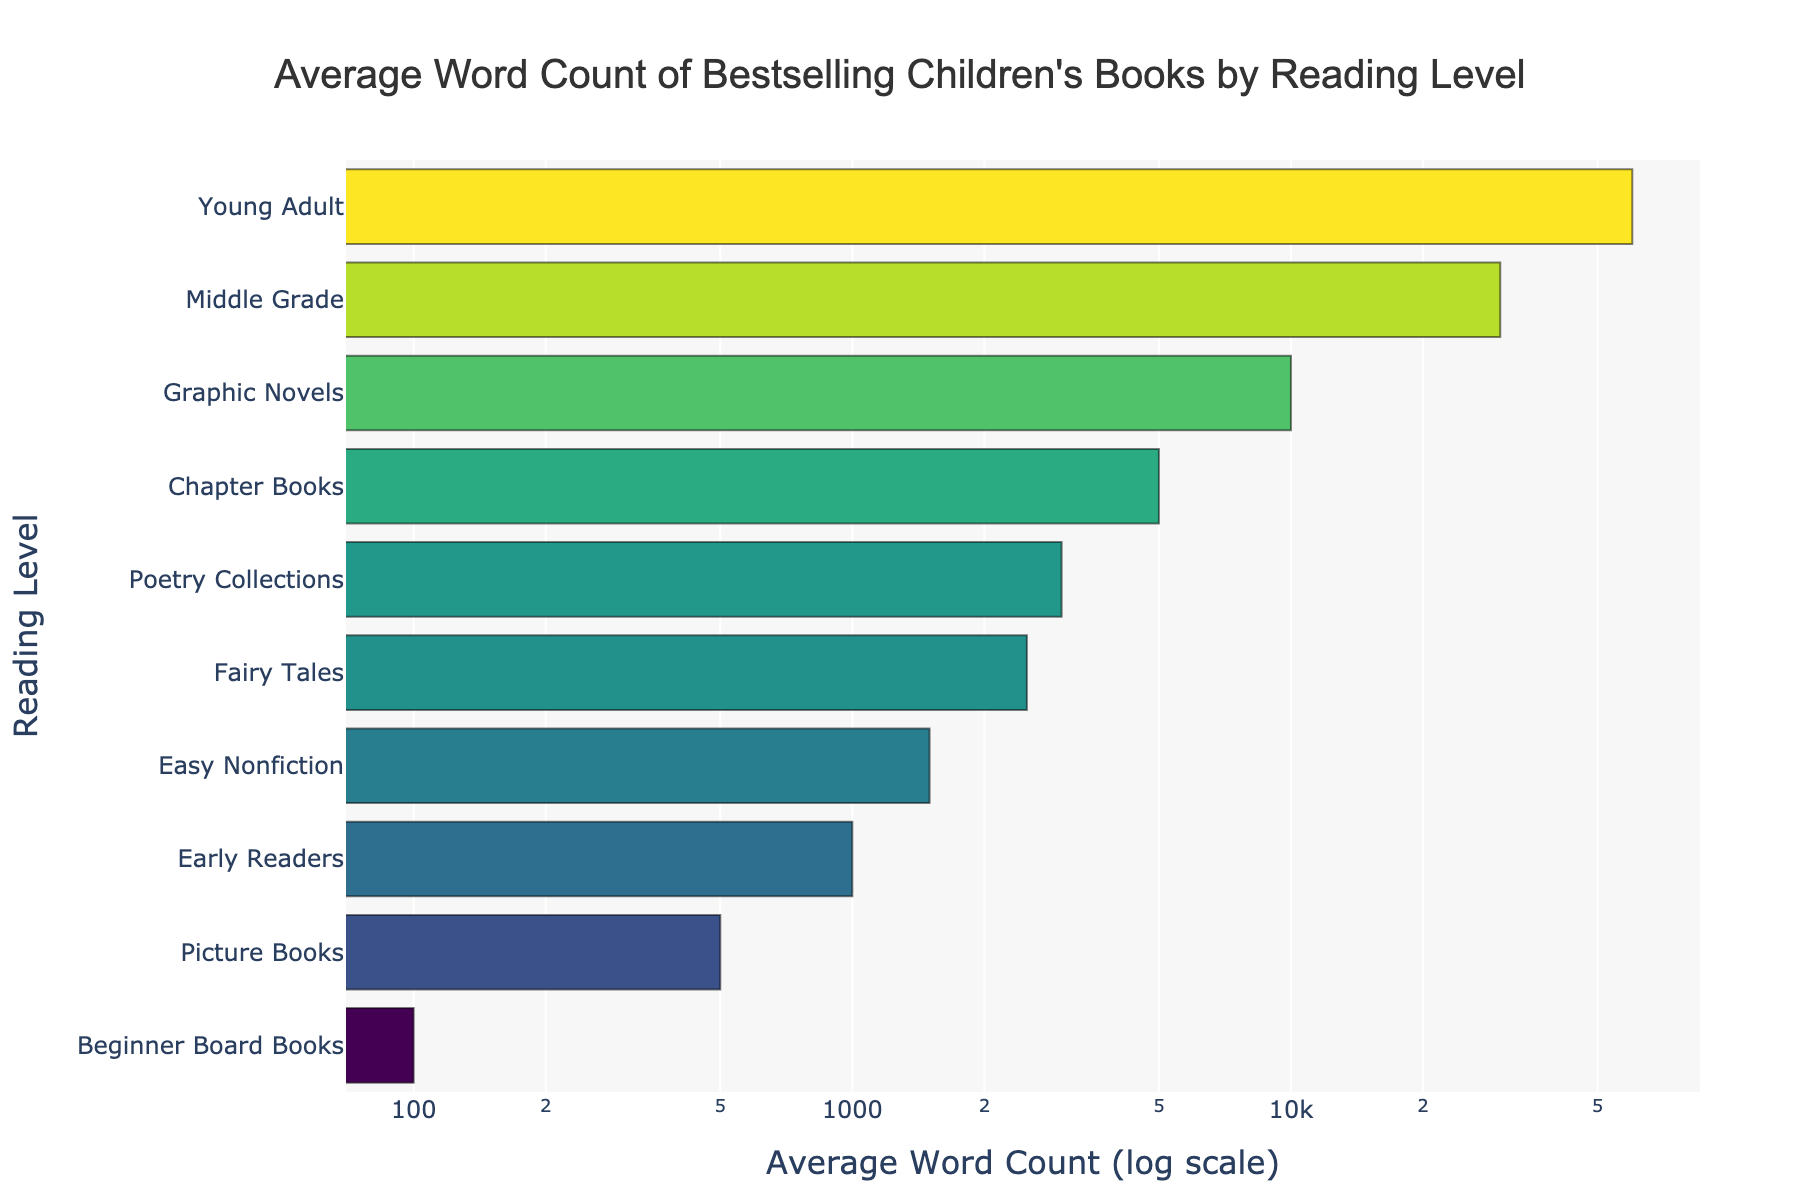Which reading level has the highest average word count? The reading level with the highest bar represents the highest average word count. In the bar chart, "Young Adult" has the highest bar indicating it has the highest average word count.
Answer: Young Adult Which reading level has the lowest average word count? The reading level with the lowest bar represents the lowest average word count. In the bar chart, "Beginner Board Books" has the smallest bar indicating it has the lowest average word count.
Answer: Beginner Board Books How many times more words does a Middle Grade book have compared to an Early Reader book? Divide the average word count of Middle Grade books by that of Early Reader books. Middle Grade is 30,000 and Early Reader is 1,000. So, 30,000 / 1,000 = 30 times more words.
Answer: 30 On average, how many more words are there in Young Adult books than in Graphic Novels? Subtract the average word count of Graphic Novels from the average word count of Young Adult books. Young Adult is 60,000 and Graphic Novels are 10,000. So, 60,000 - 10,000 = 50,000 more words.
Answer: 50,000 If you combine the average word counts of Picture Books, Early Readers, and Chapter Books, what is the total? Add the average word counts: Picture Books (500) + Early Readers (1,000) + Chapter Books (5,000) = 6,500
Answer: 6,500 Rank the reading levels from lowest to highest average word count. Sort the reading levels based on the bar lengths from shortest to longest. The order is: Beginner Board Books, Picture Books, Early Readers, Easy Nonfiction, Fairy Tales, Poetry Collections, Chapter Books, Graphic Novels, Middle Grade, Young Adult.
Answer: Beginner Board Books, Picture Books, Early Readers, Easy Nonfiction, Fairy Tales, Poetry Collections, Chapter Books, Graphic Novels, Middle Grade, Young Adult What is the difference in average word counts between the highest and lowest reading levels? Subtract the average word count of the lowest (Beginner Board Books) from the highest (Young Adult). So, 60,000 (Young Adult) - 100 (Beginner Board Books) = 59,900.
Answer: 59,900 Is the average word count of Poetry Collections greater than or less than Early Readers? Compare the bars for Poetry Collections and Early Readers. Poetry Collections has 3,000 words and Early Readers have 1,000 words, so Poetry Collections has a greater word count.
Answer: Greater 